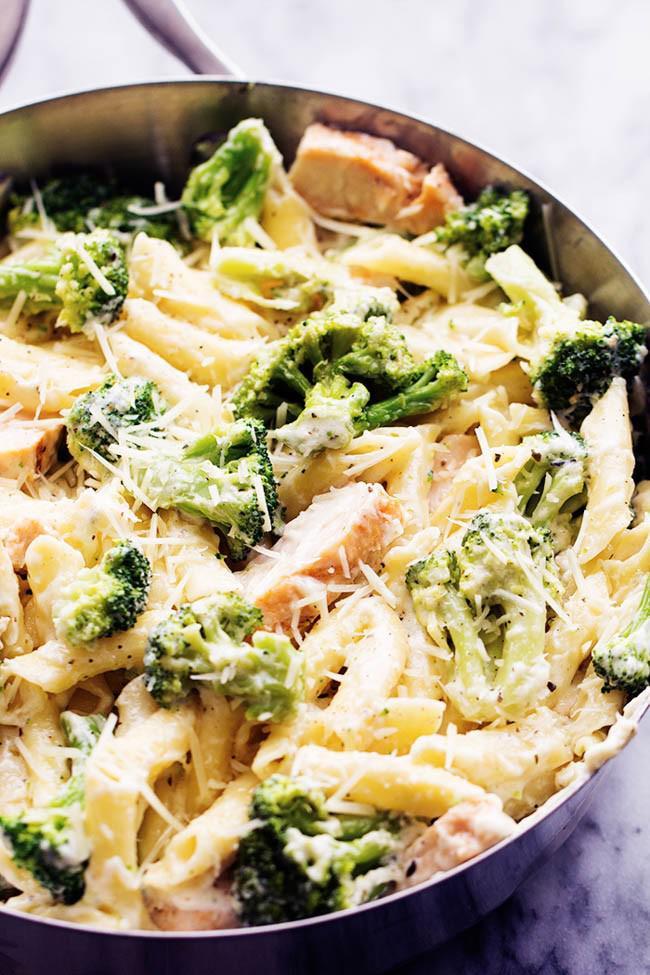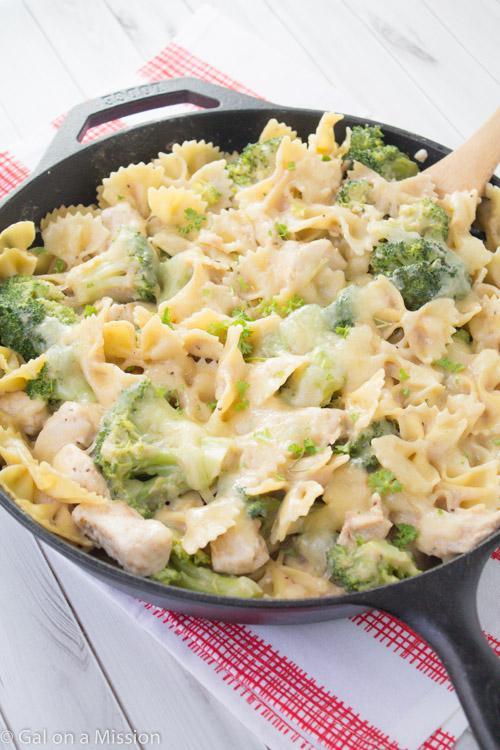The first image is the image on the left, the second image is the image on the right. Given the left and right images, does the statement "At least one of the dishes doesn't have penne pasta." hold true? Answer yes or no. Yes. 